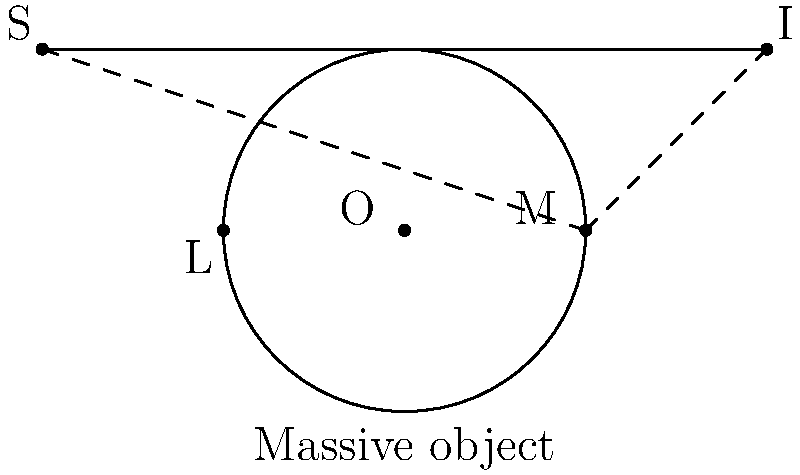In the context of gravitational lensing, explain how the ray diagram above illustrates the bending of light from a distant source S to an observer at I. How does this relate to the concept of gravitational lensing, and what implications does it have for observing distant objects in the universe? 1. The diagram shows a massive object (e.g., a galaxy or cluster) represented by the circle centered at O.

2. Light from a distant source S travels towards the massive object.

3. As the light approaches the massive object, it bends due to the curvature of spacetime caused by the object's gravity. This is represented by the solid curved line from S to I.

4. Without the massive object, light would travel in a straight line (shown by the dashed line from S to M to I).

5. The bending of light causes the observer at I to perceive the source as if it were at a different position than its actual location.

6. This phenomenon is called gravitational lensing, where the massive object acts as a "lens" that bends light.

7. The amount of bending depends on the mass of the object and the distance between the light path and the center of the massive object.

8. Gravitational lensing can magnify and distort the image of distant objects, allowing astronomers to observe galaxies and other celestial bodies that would otherwise be too faint or distant to detect.

9. Multiple images of the same source can be created if the alignment between the source, lens, and observer is precise (not shown in this diagram).

10. From a computational perspective, simulating gravitational lensing involves solving complex differential equations that describe the path of light in curved spacetime, often requiring high-performance computing and optimized algorithms.
Answer: Gravitational lensing bends light around massive objects, allowing observation of distant sources that would otherwise be invisible or distorted. 